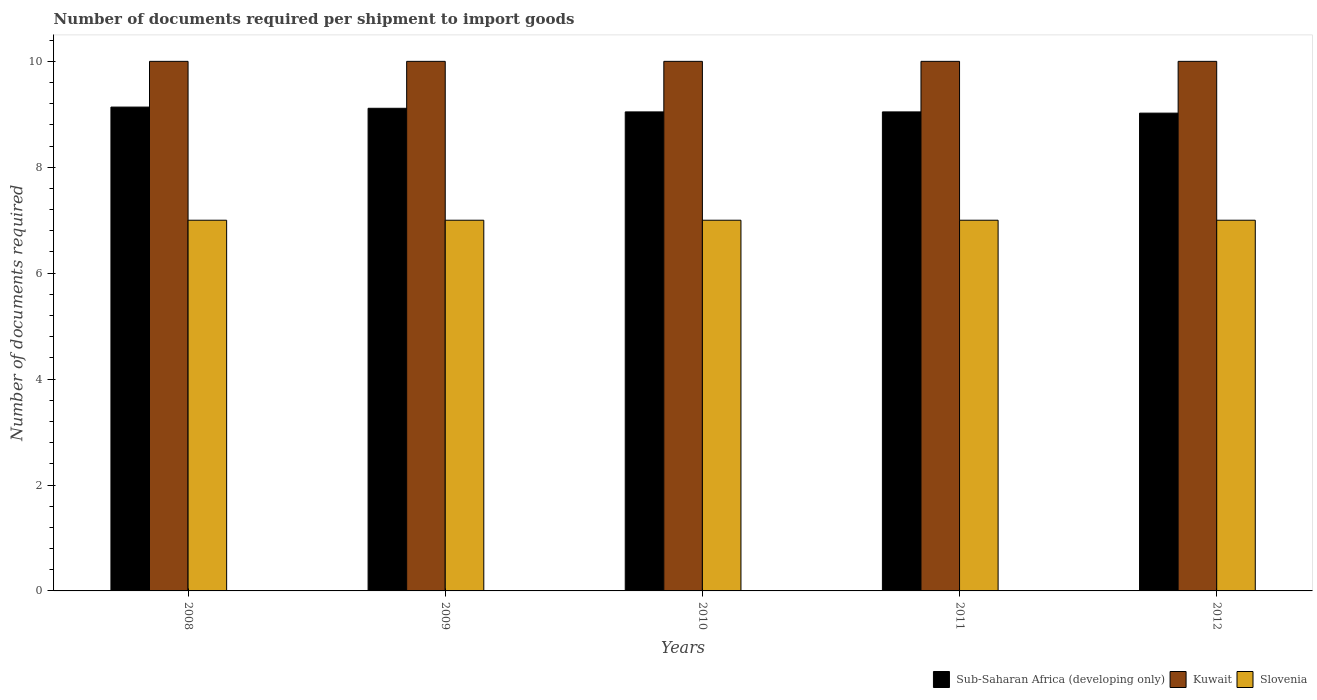How many different coloured bars are there?
Provide a succinct answer. 3. How many groups of bars are there?
Your answer should be very brief. 5. In how many cases, is the number of bars for a given year not equal to the number of legend labels?
Make the answer very short. 0. What is the number of documents required per shipment to import goods in Kuwait in 2009?
Provide a short and direct response. 10. Across all years, what is the maximum number of documents required per shipment to import goods in Sub-Saharan Africa (developing only)?
Offer a very short reply. 9.14. Across all years, what is the minimum number of documents required per shipment to import goods in Sub-Saharan Africa (developing only)?
Ensure brevity in your answer.  9.02. In which year was the number of documents required per shipment to import goods in Kuwait maximum?
Your answer should be very brief. 2008. What is the total number of documents required per shipment to import goods in Slovenia in the graph?
Provide a succinct answer. 35. What is the difference between the number of documents required per shipment to import goods in Kuwait in 2011 and the number of documents required per shipment to import goods in Slovenia in 2009?
Your answer should be very brief. 3. What is the average number of documents required per shipment to import goods in Slovenia per year?
Your answer should be very brief. 7. In the year 2011, what is the difference between the number of documents required per shipment to import goods in Slovenia and number of documents required per shipment to import goods in Kuwait?
Offer a terse response. -3. What is the ratio of the number of documents required per shipment to import goods in Sub-Saharan Africa (developing only) in 2008 to that in 2009?
Ensure brevity in your answer.  1. What is the difference between the highest and the lowest number of documents required per shipment to import goods in Kuwait?
Keep it short and to the point. 0. Is the sum of the number of documents required per shipment to import goods in Slovenia in 2010 and 2011 greater than the maximum number of documents required per shipment to import goods in Kuwait across all years?
Give a very brief answer. Yes. What does the 3rd bar from the left in 2012 represents?
Your response must be concise. Slovenia. What does the 2nd bar from the right in 2008 represents?
Give a very brief answer. Kuwait. What is the difference between two consecutive major ticks on the Y-axis?
Your answer should be compact. 2. Are the values on the major ticks of Y-axis written in scientific E-notation?
Provide a succinct answer. No. Does the graph contain any zero values?
Make the answer very short. No. How many legend labels are there?
Your answer should be compact. 3. How are the legend labels stacked?
Provide a short and direct response. Horizontal. What is the title of the graph?
Provide a short and direct response. Number of documents required per shipment to import goods. Does "Mauritius" appear as one of the legend labels in the graph?
Keep it short and to the point. No. What is the label or title of the X-axis?
Provide a short and direct response. Years. What is the label or title of the Y-axis?
Ensure brevity in your answer.  Number of documents required. What is the Number of documents required of Sub-Saharan Africa (developing only) in 2008?
Provide a succinct answer. 9.14. What is the Number of documents required in Kuwait in 2008?
Offer a very short reply. 10. What is the Number of documents required in Sub-Saharan Africa (developing only) in 2009?
Ensure brevity in your answer.  9.11. What is the Number of documents required in Kuwait in 2009?
Make the answer very short. 10. What is the Number of documents required of Sub-Saharan Africa (developing only) in 2010?
Offer a terse response. 9.05. What is the Number of documents required of Sub-Saharan Africa (developing only) in 2011?
Your response must be concise. 9.05. What is the Number of documents required in Slovenia in 2011?
Your response must be concise. 7. What is the Number of documents required in Sub-Saharan Africa (developing only) in 2012?
Keep it short and to the point. 9.02. What is the Number of documents required of Slovenia in 2012?
Offer a terse response. 7. Across all years, what is the maximum Number of documents required in Sub-Saharan Africa (developing only)?
Your answer should be compact. 9.14. Across all years, what is the maximum Number of documents required of Slovenia?
Make the answer very short. 7. Across all years, what is the minimum Number of documents required of Sub-Saharan Africa (developing only)?
Offer a terse response. 9.02. Across all years, what is the minimum Number of documents required of Slovenia?
Your response must be concise. 7. What is the total Number of documents required of Sub-Saharan Africa (developing only) in the graph?
Your response must be concise. 45.36. What is the total Number of documents required of Slovenia in the graph?
Offer a very short reply. 35. What is the difference between the Number of documents required in Sub-Saharan Africa (developing only) in 2008 and that in 2009?
Ensure brevity in your answer.  0.02. What is the difference between the Number of documents required of Sub-Saharan Africa (developing only) in 2008 and that in 2010?
Your answer should be compact. 0.09. What is the difference between the Number of documents required of Sub-Saharan Africa (developing only) in 2008 and that in 2011?
Your response must be concise. 0.09. What is the difference between the Number of documents required in Kuwait in 2008 and that in 2011?
Your answer should be compact. 0. What is the difference between the Number of documents required in Slovenia in 2008 and that in 2011?
Your answer should be compact. 0. What is the difference between the Number of documents required of Sub-Saharan Africa (developing only) in 2008 and that in 2012?
Your answer should be compact. 0.11. What is the difference between the Number of documents required in Slovenia in 2008 and that in 2012?
Your answer should be compact. 0. What is the difference between the Number of documents required in Sub-Saharan Africa (developing only) in 2009 and that in 2010?
Make the answer very short. 0.07. What is the difference between the Number of documents required in Kuwait in 2009 and that in 2010?
Your answer should be very brief. 0. What is the difference between the Number of documents required of Sub-Saharan Africa (developing only) in 2009 and that in 2011?
Provide a short and direct response. 0.07. What is the difference between the Number of documents required of Kuwait in 2009 and that in 2011?
Your response must be concise. 0. What is the difference between the Number of documents required of Slovenia in 2009 and that in 2011?
Offer a terse response. 0. What is the difference between the Number of documents required of Sub-Saharan Africa (developing only) in 2009 and that in 2012?
Give a very brief answer. 0.09. What is the difference between the Number of documents required in Slovenia in 2009 and that in 2012?
Ensure brevity in your answer.  0. What is the difference between the Number of documents required in Sub-Saharan Africa (developing only) in 2010 and that in 2011?
Your answer should be compact. 0. What is the difference between the Number of documents required in Sub-Saharan Africa (developing only) in 2010 and that in 2012?
Offer a very short reply. 0.02. What is the difference between the Number of documents required in Sub-Saharan Africa (developing only) in 2011 and that in 2012?
Offer a very short reply. 0.02. What is the difference between the Number of documents required in Kuwait in 2011 and that in 2012?
Provide a succinct answer. 0. What is the difference between the Number of documents required of Slovenia in 2011 and that in 2012?
Make the answer very short. 0. What is the difference between the Number of documents required in Sub-Saharan Africa (developing only) in 2008 and the Number of documents required in Kuwait in 2009?
Ensure brevity in your answer.  -0.86. What is the difference between the Number of documents required in Sub-Saharan Africa (developing only) in 2008 and the Number of documents required in Slovenia in 2009?
Give a very brief answer. 2.14. What is the difference between the Number of documents required of Sub-Saharan Africa (developing only) in 2008 and the Number of documents required of Kuwait in 2010?
Provide a short and direct response. -0.86. What is the difference between the Number of documents required of Sub-Saharan Africa (developing only) in 2008 and the Number of documents required of Slovenia in 2010?
Offer a terse response. 2.14. What is the difference between the Number of documents required in Sub-Saharan Africa (developing only) in 2008 and the Number of documents required in Kuwait in 2011?
Keep it short and to the point. -0.86. What is the difference between the Number of documents required of Sub-Saharan Africa (developing only) in 2008 and the Number of documents required of Slovenia in 2011?
Provide a succinct answer. 2.14. What is the difference between the Number of documents required in Kuwait in 2008 and the Number of documents required in Slovenia in 2011?
Give a very brief answer. 3. What is the difference between the Number of documents required in Sub-Saharan Africa (developing only) in 2008 and the Number of documents required in Kuwait in 2012?
Your response must be concise. -0.86. What is the difference between the Number of documents required of Sub-Saharan Africa (developing only) in 2008 and the Number of documents required of Slovenia in 2012?
Make the answer very short. 2.14. What is the difference between the Number of documents required of Sub-Saharan Africa (developing only) in 2009 and the Number of documents required of Kuwait in 2010?
Provide a succinct answer. -0.89. What is the difference between the Number of documents required of Sub-Saharan Africa (developing only) in 2009 and the Number of documents required of Slovenia in 2010?
Offer a very short reply. 2.11. What is the difference between the Number of documents required in Sub-Saharan Africa (developing only) in 2009 and the Number of documents required in Kuwait in 2011?
Your answer should be very brief. -0.89. What is the difference between the Number of documents required of Sub-Saharan Africa (developing only) in 2009 and the Number of documents required of Slovenia in 2011?
Make the answer very short. 2.11. What is the difference between the Number of documents required in Kuwait in 2009 and the Number of documents required in Slovenia in 2011?
Keep it short and to the point. 3. What is the difference between the Number of documents required of Sub-Saharan Africa (developing only) in 2009 and the Number of documents required of Kuwait in 2012?
Provide a succinct answer. -0.89. What is the difference between the Number of documents required in Sub-Saharan Africa (developing only) in 2009 and the Number of documents required in Slovenia in 2012?
Provide a short and direct response. 2.11. What is the difference between the Number of documents required in Sub-Saharan Africa (developing only) in 2010 and the Number of documents required in Kuwait in 2011?
Offer a very short reply. -0.95. What is the difference between the Number of documents required of Sub-Saharan Africa (developing only) in 2010 and the Number of documents required of Slovenia in 2011?
Keep it short and to the point. 2.05. What is the difference between the Number of documents required in Kuwait in 2010 and the Number of documents required in Slovenia in 2011?
Make the answer very short. 3. What is the difference between the Number of documents required of Sub-Saharan Africa (developing only) in 2010 and the Number of documents required of Kuwait in 2012?
Offer a very short reply. -0.95. What is the difference between the Number of documents required of Sub-Saharan Africa (developing only) in 2010 and the Number of documents required of Slovenia in 2012?
Keep it short and to the point. 2.05. What is the difference between the Number of documents required of Sub-Saharan Africa (developing only) in 2011 and the Number of documents required of Kuwait in 2012?
Your response must be concise. -0.95. What is the difference between the Number of documents required of Sub-Saharan Africa (developing only) in 2011 and the Number of documents required of Slovenia in 2012?
Your answer should be compact. 2.05. What is the difference between the Number of documents required of Kuwait in 2011 and the Number of documents required of Slovenia in 2012?
Ensure brevity in your answer.  3. What is the average Number of documents required in Sub-Saharan Africa (developing only) per year?
Your response must be concise. 9.07. What is the average Number of documents required in Kuwait per year?
Give a very brief answer. 10. In the year 2008, what is the difference between the Number of documents required of Sub-Saharan Africa (developing only) and Number of documents required of Kuwait?
Make the answer very short. -0.86. In the year 2008, what is the difference between the Number of documents required of Sub-Saharan Africa (developing only) and Number of documents required of Slovenia?
Give a very brief answer. 2.14. In the year 2009, what is the difference between the Number of documents required in Sub-Saharan Africa (developing only) and Number of documents required in Kuwait?
Provide a short and direct response. -0.89. In the year 2009, what is the difference between the Number of documents required in Sub-Saharan Africa (developing only) and Number of documents required in Slovenia?
Ensure brevity in your answer.  2.11. In the year 2009, what is the difference between the Number of documents required of Kuwait and Number of documents required of Slovenia?
Provide a short and direct response. 3. In the year 2010, what is the difference between the Number of documents required of Sub-Saharan Africa (developing only) and Number of documents required of Kuwait?
Your response must be concise. -0.95. In the year 2010, what is the difference between the Number of documents required of Sub-Saharan Africa (developing only) and Number of documents required of Slovenia?
Provide a succinct answer. 2.05. In the year 2010, what is the difference between the Number of documents required of Kuwait and Number of documents required of Slovenia?
Your answer should be compact. 3. In the year 2011, what is the difference between the Number of documents required of Sub-Saharan Africa (developing only) and Number of documents required of Kuwait?
Offer a very short reply. -0.95. In the year 2011, what is the difference between the Number of documents required in Sub-Saharan Africa (developing only) and Number of documents required in Slovenia?
Your answer should be very brief. 2.05. In the year 2012, what is the difference between the Number of documents required in Sub-Saharan Africa (developing only) and Number of documents required in Kuwait?
Offer a very short reply. -0.98. In the year 2012, what is the difference between the Number of documents required in Sub-Saharan Africa (developing only) and Number of documents required in Slovenia?
Offer a terse response. 2.02. In the year 2012, what is the difference between the Number of documents required in Kuwait and Number of documents required in Slovenia?
Give a very brief answer. 3. What is the ratio of the Number of documents required in Sub-Saharan Africa (developing only) in 2008 to that in 2009?
Your answer should be very brief. 1. What is the ratio of the Number of documents required of Kuwait in 2008 to that in 2009?
Your answer should be very brief. 1. What is the ratio of the Number of documents required in Slovenia in 2008 to that in 2009?
Keep it short and to the point. 1. What is the ratio of the Number of documents required in Kuwait in 2008 to that in 2011?
Your answer should be very brief. 1. What is the ratio of the Number of documents required in Sub-Saharan Africa (developing only) in 2008 to that in 2012?
Provide a succinct answer. 1.01. What is the ratio of the Number of documents required of Kuwait in 2008 to that in 2012?
Your answer should be very brief. 1. What is the ratio of the Number of documents required in Slovenia in 2008 to that in 2012?
Offer a very short reply. 1. What is the ratio of the Number of documents required in Sub-Saharan Africa (developing only) in 2009 to that in 2010?
Ensure brevity in your answer.  1.01. What is the ratio of the Number of documents required in Kuwait in 2009 to that in 2010?
Give a very brief answer. 1. What is the ratio of the Number of documents required in Slovenia in 2009 to that in 2010?
Offer a very short reply. 1. What is the ratio of the Number of documents required of Sub-Saharan Africa (developing only) in 2009 to that in 2011?
Make the answer very short. 1.01. What is the ratio of the Number of documents required in Kuwait in 2009 to that in 2011?
Offer a very short reply. 1. What is the ratio of the Number of documents required in Sub-Saharan Africa (developing only) in 2009 to that in 2012?
Give a very brief answer. 1.01. What is the ratio of the Number of documents required in Kuwait in 2009 to that in 2012?
Your response must be concise. 1. What is the ratio of the Number of documents required of Sub-Saharan Africa (developing only) in 2010 to that in 2011?
Offer a very short reply. 1. What is the ratio of the Number of documents required in Slovenia in 2010 to that in 2011?
Offer a terse response. 1. What is the ratio of the Number of documents required in Sub-Saharan Africa (developing only) in 2010 to that in 2012?
Your answer should be compact. 1. What is the ratio of the Number of documents required of Kuwait in 2010 to that in 2012?
Offer a very short reply. 1. What is the ratio of the Number of documents required of Kuwait in 2011 to that in 2012?
Make the answer very short. 1. What is the ratio of the Number of documents required in Slovenia in 2011 to that in 2012?
Give a very brief answer. 1. What is the difference between the highest and the second highest Number of documents required of Sub-Saharan Africa (developing only)?
Give a very brief answer. 0.02. What is the difference between the highest and the lowest Number of documents required in Sub-Saharan Africa (developing only)?
Keep it short and to the point. 0.11. What is the difference between the highest and the lowest Number of documents required in Kuwait?
Your answer should be very brief. 0. 